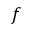Convert formula to latex. <formula><loc_0><loc_0><loc_500><loc_500>f</formula> 